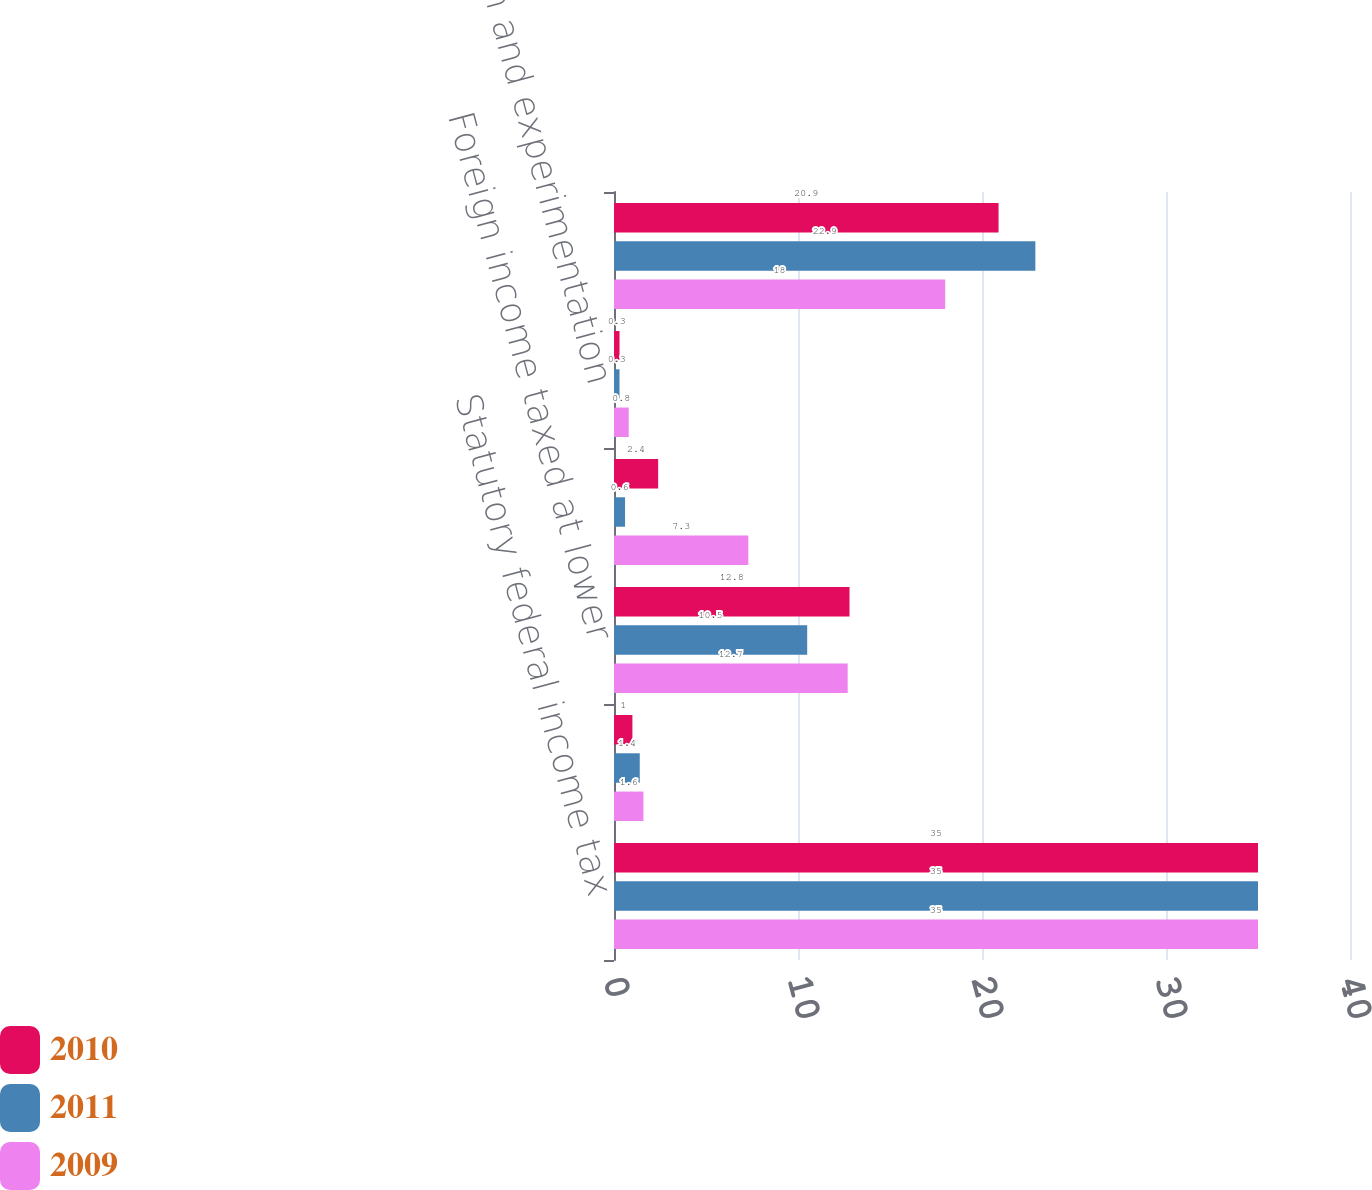Convert chart to OTSL. <chart><loc_0><loc_0><loc_500><loc_500><stacked_bar_chart><ecel><fcel>Statutory federal income tax<fcel>State income taxes (net of<fcel>Foreign income taxed at lower<fcel>Resolution of uncertain tax<fcel>Research and experimentation<fcel>Effective income tax rate<nl><fcel>2010<fcel>35<fcel>1<fcel>12.8<fcel>2.4<fcel>0.3<fcel>20.9<nl><fcel>2011<fcel>35<fcel>1.4<fcel>10.5<fcel>0.6<fcel>0.3<fcel>22.9<nl><fcel>2009<fcel>35<fcel>1.6<fcel>12.7<fcel>7.3<fcel>0.8<fcel>18<nl></chart> 